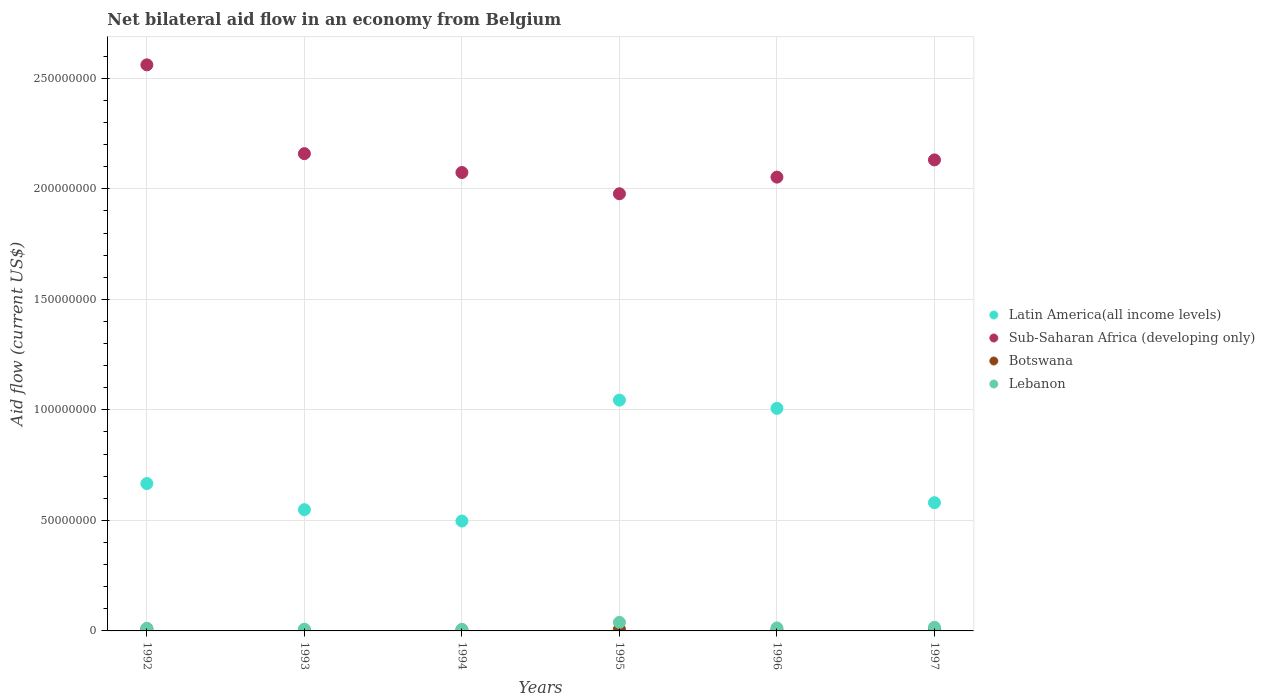What is the net bilateral aid flow in Sub-Saharan Africa (developing only) in 1993?
Provide a succinct answer. 2.16e+08. Across all years, what is the maximum net bilateral aid flow in Botswana?
Keep it short and to the point. 9.20e+05. Across all years, what is the minimum net bilateral aid flow in Sub-Saharan Africa (developing only)?
Your answer should be compact. 1.98e+08. What is the total net bilateral aid flow in Latin America(all income levels) in the graph?
Give a very brief answer. 4.34e+08. What is the difference between the net bilateral aid flow in Latin America(all income levels) in 1994 and that in 1997?
Keep it short and to the point. -8.31e+06. What is the difference between the net bilateral aid flow in Botswana in 1992 and the net bilateral aid flow in Lebanon in 1997?
Give a very brief answer. -7.40e+05. What is the average net bilateral aid flow in Botswana per year?
Give a very brief answer. 5.25e+05. In the year 1997, what is the difference between the net bilateral aid flow in Sub-Saharan Africa (developing only) and net bilateral aid flow in Botswana?
Your response must be concise. 2.13e+08. In how many years, is the net bilateral aid flow in Latin America(all income levels) greater than 30000000 US$?
Your answer should be compact. 6. What is the ratio of the net bilateral aid flow in Botswana in 1992 to that in 1995?
Offer a terse response. 1.23. Is the difference between the net bilateral aid flow in Sub-Saharan Africa (developing only) in 1996 and 1997 greater than the difference between the net bilateral aid flow in Botswana in 1996 and 1997?
Ensure brevity in your answer.  No. What is the difference between the highest and the second highest net bilateral aid flow in Latin America(all income levels)?
Keep it short and to the point. 3.74e+06. What is the difference between the highest and the lowest net bilateral aid flow in Botswana?
Offer a very short reply. 6.50e+05. Is it the case that in every year, the sum of the net bilateral aid flow in Lebanon and net bilateral aid flow in Botswana  is greater than the sum of net bilateral aid flow in Latin America(all income levels) and net bilateral aid flow in Sub-Saharan Africa (developing only)?
Provide a short and direct response. Yes. What is the difference between two consecutive major ticks on the Y-axis?
Ensure brevity in your answer.  5.00e+07. Are the values on the major ticks of Y-axis written in scientific E-notation?
Your answer should be very brief. No. Does the graph contain grids?
Provide a short and direct response. Yes. Where does the legend appear in the graph?
Your answer should be compact. Center right. How are the legend labels stacked?
Make the answer very short. Vertical. What is the title of the graph?
Keep it short and to the point. Net bilateral aid flow in an economy from Belgium. Does "South Asia" appear as one of the legend labels in the graph?
Keep it short and to the point. No. What is the label or title of the X-axis?
Your answer should be very brief. Years. What is the label or title of the Y-axis?
Offer a very short reply. Aid flow (current US$). What is the Aid flow (current US$) in Latin America(all income levels) in 1992?
Give a very brief answer. 6.67e+07. What is the Aid flow (current US$) of Sub-Saharan Africa (developing only) in 1992?
Provide a short and direct response. 2.56e+08. What is the Aid flow (current US$) in Botswana in 1992?
Ensure brevity in your answer.  9.20e+05. What is the Aid flow (current US$) of Lebanon in 1992?
Provide a short and direct response. 1.18e+06. What is the Aid flow (current US$) of Latin America(all income levels) in 1993?
Give a very brief answer. 5.49e+07. What is the Aid flow (current US$) of Sub-Saharan Africa (developing only) in 1993?
Your answer should be very brief. 2.16e+08. What is the Aid flow (current US$) in Lebanon in 1993?
Make the answer very short. 7.80e+05. What is the Aid flow (current US$) in Latin America(all income levels) in 1994?
Your answer should be very brief. 4.97e+07. What is the Aid flow (current US$) of Sub-Saharan Africa (developing only) in 1994?
Ensure brevity in your answer.  2.07e+08. What is the Aid flow (current US$) of Lebanon in 1994?
Offer a terse response. 7.10e+05. What is the Aid flow (current US$) of Latin America(all income levels) in 1995?
Your answer should be compact. 1.04e+08. What is the Aid flow (current US$) of Sub-Saharan Africa (developing only) in 1995?
Your response must be concise. 1.98e+08. What is the Aid flow (current US$) in Botswana in 1995?
Offer a very short reply. 7.50e+05. What is the Aid flow (current US$) in Lebanon in 1995?
Provide a succinct answer. 3.86e+06. What is the Aid flow (current US$) of Latin America(all income levels) in 1996?
Offer a terse response. 1.01e+08. What is the Aid flow (current US$) of Sub-Saharan Africa (developing only) in 1996?
Make the answer very short. 2.05e+08. What is the Aid flow (current US$) of Botswana in 1996?
Your answer should be very brief. 4.20e+05. What is the Aid flow (current US$) in Lebanon in 1996?
Your answer should be compact. 1.35e+06. What is the Aid flow (current US$) of Latin America(all income levels) in 1997?
Your answer should be very brief. 5.80e+07. What is the Aid flow (current US$) of Sub-Saharan Africa (developing only) in 1997?
Make the answer very short. 2.13e+08. What is the Aid flow (current US$) of Botswana in 1997?
Ensure brevity in your answer.  4.00e+05. What is the Aid flow (current US$) in Lebanon in 1997?
Offer a terse response. 1.66e+06. Across all years, what is the maximum Aid flow (current US$) in Latin America(all income levels)?
Offer a terse response. 1.04e+08. Across all years, what is the maximum Aid flow (current US$) of Sub-Saharan Africa (developing only)?
Your response must be concise. 2.56e+08. Across all years, what is the maximum Aid flow (current US$) of Botswana?
Offer a terse response. 9.20e+05. Across all years, what is the maximum Aid flow (current US$) of Lebanon?
Your answer should be compact. 3.86e+06. Across all years, what is the minimum Aid flow (current US$) in Latin America(all income levels)?
Offer a very short reply. 4.97e+07. Across all years, what is the minimum Aid flow (current US$) in Sub-Saharan Africa (developing only)?
Keep it short and to the point. 1.98e+08. Across all years, what is the minimum Aid flow (current US$) of Botswana?
Ensure brevity in your answer.  2.70e+05. Across all years, what is the minimum Aid flow (current US$) of Lebanon?
Offer a very short reply. 7.10e+05. What is the total Aid flow (current US$) of Latin America(all income levels) in the graph?
Your answer should be very brief. 4.34e+08. What is the total Aid flow (current US$) of Sub-Saharan Africa (developing only) in the graph?
Offer a terse response. 1.30e+09. What is the total Aid flow (current US$) in Botswana in the graph?
Give a very brief answer. 3.15e+06. What is the total Aid flow (current US$) of Lebanon in the graph?
Make the answer very short. 9.54e+06. What is the difference between the Aid flow (current US$) of Latin America(all income levels) in 1992 and that in 1993?
Your answer should be very brief. 1.18e+07. What is the difference between the Aid flow (current US$) in Sub-Saharan Africa (developing only) in 1992 and that in 1993?
Provide a succinct answer. 4.02e+07. What is the difference between the Aid flow (current US$) in Botswana in 1992 and that in 1993?
Keep it short and to the point. 6.50e+05. What is the difference between the Aid flow (current US$) in Latin America(all income levels) in 1992 and that in 1994?
Offer a terse response. 1.70e+07. What is the difference between the Aid flow (current US$) in Sub-Saharan Africa (developing only) in 1992 and that in 1994?
Your answer should be very brief. 4.87e+07. What is the difference between the Aid flow (current US$) of Botswana in 1992 and that in 1994?
Give a very brief answer. 5.30e+05. What is the difference between the Aid flow (current US$) in Latin America(all income levels) in 1992 and that in 1995?
Offer a very short reply. -3.78e+07. What is the difference between the Aid flow (current US$) in Sub-Saharan Africa (developing only) in 1992 and that in 1995?
Make the answer very short. 5.83e+07. What is the difference between the Aid flow (current US$) of Botswana in 1992 and that in 1995?
Make the answer very short. 1.70e+05. What is the difference between the Aid flow (current US$) in Lebanon in 1992 and that in 1995?
Your response must be concise. -2.68e+06. What is the difference between the Aid flow (current US$) of Latin America(all income levels) in 1992 and that in 1996?
Keep it short and to the point. -3.40e+07. What is the difference between the Aid flow (current US$) in Sub-Saharan Africa (developing only) in 1992 and that in 1996?
Your answer should be very brief. 5.08e+07. What is the difference between the Aid flow (current US$) in Latin America(all income levels) in 1992 and that in 1997?
Offer a terse response. 8.66e+06. What is the difference between the Aid flow (current US$) of Sub-Saharan Africa (developing only) in 1992 and that in 1997?
Ensure brevity in your answer.  4.30e+07. What is the difference between the Aid flow (current US$) in Botswana in 1992 and that in 1997?
Provide a succinct answer. 5.20e+05. What is the difference between the Aid flow (current US$) in Lebanon in 1992 and that in 1997?
Your response must be concise. -4.80e+05. What is the difference between the Aid flow (current US$) of Latin America(all income levels) in 1993 and that in 1994?
Give a very brief answer. 5.16e+06. What is the difference between the Aid flow (current US$) of Sub-Saharan Africa (developing only) in 1993 and that in 1994?
Offer a very short reply. 8.53e+06. What is the difference between the Aid flow (current US$) of Botswana in 1993 and that in 1994?
Offer a terse response. -1.20e+05. What is the difference between the Aid flow (current US$) of Latin America(all income levels) in 1993 and that in 1995?
Ensure brevity in your answer.  -4.96e+07. What is the difference between the Aid flow (current US$) of Sub-Saharan Africa (developing only) in 1993 and that in 1995?
Give a very brief answer. 1.82e+07. What is the difference between the Aid flow (current US$) in Botswana in 1993 and that in 1995?
Your response must be concise. -4.80e+05. What is the difference between the Aid flow (current US$) of Lebanon in 1993 and that in 1995?
Give a very brief answer. -3.08e+06. What is the difference between the Aid flow (current US$) in Latin America(all income levels) in 1993 and that in 1996?
Keep it short and to the point. -4.58e+07. What is the difference between the Aid flow (current US$) of Sub-Saharan Africa (developing only) in 1993 and that in 1996?
Provide a succinct answer. 1.06e+07. What is the difference between the Aid flow (current US$) in Botswana in 1993 and that in 1996?
Offer a very short reply. -1.50e+05. What is the difference between the Aid flow (current US$) in Lebanon in 1993 and that in 1996?
Give a very brief answer. -5.70e+05. What is the difference between the Aid flow (current US$) in Latin America(all income levels) in 1993 and that in 1997?
Ensure brevity in your answer.  -3.15e+06. What is the difference between the Aid flow (current US$) in Sub-Saharan Africa (developing only) in 1993 and that in 1997?
Keep it short and to the point. 2.83e+06. What is the difference between the Aid flow (current US$) of Lebanon in 1993 and that in 1997?
Give a very brief answer. -8.80e+05. What is the difference between the Aid flow (current US$) in Latin America(all income levels) in 1994 and that in 1995?
Give a very brief answer. -5.47e+07. What is the difference between the Aid flow (current US$) in Sub-Saharan Africa (developing only) in 1994 and that in 1995?
Make the answer very short. 9.62e+06. What is the difference between the Aid flow (current US$) in Botswana in 1994 and that in 1995?
Your answer should be very brief. -3.60e+05. What is the difference between the Aid flow (current US$) in Lebanon in 1994 and that in 1995?
Your answer should be very brief. -3.15e+06. What is the difference between the Aid flow (current US$) of Latin America(all income levels) in 1994 and that in 1996?
Keep it short and to the point. -5.10e+07. What is the difference between the Aid flow (current US$) in Sub-Saharan Africa (developing only) in 1994 and that in 1996?
Provide a short and direct response. 2.09e+06. What is the difference between the Aid flow (current US$) of Lebanon in 1994 and that in 1996?
Your response must be concise. -6.40e+05. What is the difference between the Aid flow (current US$) of Latin America(all income levels) in 1994 and that in 1997?
Your answer should be very brief. -8.31e+06. What is the difference between the Aid flow (current US$) of Sub-Saharan Africa (developing only) in 1994 and that in 1997?
Keep it short and to the point. -5.70e+06. What is the difference between the Aid flow (current US$) of Botswana in 1994 and that in 1997?
Give a very brief answer. -10000. What is the difference between the Aid flow (current US$) of Lebanon in 1994 and that in 1997?
Provide a short and direct response. -9.50e+05. What is the difference between the Aid flow (current US$) in Latin America(all income levels) in 1995 and that in 1996?
Your response must be concise. 3.74e+06. What is the difference between the Aid flow (current US$) in Sub-Saharan Africa (developing only) in 1995 and that in 1996?
Keep it short and to the point. -7.53e+06. What is the difference between the Aid flow (current US$) of Lebanon in 1995 and that in 1996?
Your answer should be very brief. 2.51e+06. What is the difference between the Aid flow (current US$) in Latin America(all income levels) in 1995 and that in 1997?
Make the answer very short. 4.64e+07. What is the difference between the Aid flow (current US$) of Sub-Saharan Africa (developing only) in 1995 and that in 1997?
Make the answer very short. -1.53e+07. What is the difference between the Aid flow (current US$) in Botswana in 1995 and that in 1997?
Make the answer very short. 3.50e+05. What is the difference between the Aid flow (current US$) of Lebanon in 1995 and that in 1997?
Your answer should be compact. 2.20e+06. What is the difference between the Aid flow (current US$) of Latin America(all income levels) in 1996 and that in 1997?
Your response must be concise. 4.27e+07. What is the difference between the Aid flow (current US$) in Sub-Saharan Africa (developing only) in 1996 and that in 1997?
Offer a terse response. -7.79e+06. What is the difference between the Aid flow (current US$) in Botswana in 1996 and that in 1997?
Your answer should be compact. 2.00e+04. What is the difference between the Aid flow (current US$) in Lebanon in 1996 and that in 1997?
Give a very brief answer. -3.10e+05. What is the difference between the Aid flow (current US$) of Latin America(all income levels) in 1992 and the Aid flow (current US$) of Sub-Saharan Africa (developing only) in 1993?
Your answer should be very brief. -1.49e+08. What is the difference between the Aid flow (current US$) of Latin America(all income levels) in 1992 and the Aid flow (current US$) of Botswana in 1993?
Give a very brief answer. 6.64e+07. What is the difference between the Aid flow (current US$) in Latin America(all income levels) in 1992 and the Aid flow (current US$) in Lebanon in 1993?
Your answer should be very brief. 6.59e+07. What is the difference between the Aid flow (current US$) of Sub-Saharan Africa (developing only) in 1992 and the Aid flow (current US$) of Botswana in 1993?
Offer a terse response. 2.56e+08. What is the difference between the Aid flow (current US$) in Sub-Saharan Africa (developing only) in 1992 and the Aid flow (current US$) in Lebanon in 1993?
Your response must be concise. 2.55e+08. What is the difference between the Aid flow (current US$) in Latin America(all income levels) in 1992 and the Aid flow (current US$) in Sub-Saharan Africa (developing only) in 1994?
Your response must be concise. -1.41e+08. What is the difference between the Aid flow (current US$) in Latin America(all income levels) in 1992 and the Aid flow (current US$) in Botswana in 1994?
Provide a succinct answer. 6.63e+07. What is the difference between the Aid flow (current US$) in Latin America(all income levels) in 1992 and the Aid flow (current US$) in Lebanon in 1994?
Ensure brevity in your answer.  6.60e+07. What is the difference between the Aid flow (current US$) in Sub-Saharan Africa (developing only) in 1992 and the Aid flow (current US$) in Botswana in 1994?
Your answer should be very brief. 2.56e+08. What is the difference between the Aid flow (current US$) of Sub-Saharan Africa (developing only) in 1992 and the Aid flow (current US$) of Lebanon in 1994?
Ensure brevity in your answer.  2.55e+08. What is the difference between the Aid flow (current US$) of Latin America(all income levels) in 1992 and the Aid flow (current US$) of Sub-Saharan Africa (developing only) in 1995?
Give a very brief answer. -1.31e+08. What is the difference between the Aid flow (current US$) of Latin America(all income levels) in 1992 and the Aid flow (current US$) of Botswana in 1995?
Your answer should be very brief. 6.59e+07. What is the difference between the Aid flow (current US$) of Latin America(all income levels) in 1992 and the Aid flow (current US$) of Lebanon in 1995?
Provide a short and direct response. 6.28e+07. What is the difference between the Aid flow (current US$) in Sub-Saharan Africa (developing only) in 1992 and the Aid flow (current US$) in Botswana in 1995?
Your answer should be compact. 2.55e+08. What is the difference between the Aid flow (current US$) in Sub-Saharan Africa (developing only) in 1992 and the Aid flow (current US$) in Lebanon in 1995?
Ensure brevity in your answer.  2.52e+08. What is the difference between the Aid flow (current US$) of Botswana in 1992 and the Aid flow (current US$) of Lebanon in 1995?
Your response must be concise. -2.94e+06. What is the difference between the Aid flow (current US$) of Latin America(all income levels) in 1992 and the Aid flow (current US$) of Sub-Saharan Africa (developing only) in 1996?
Offer a terse response. -1.39e+08. What is the difference between the Aid flow (current US$) in Latin America(all income levels) in 1992 and the Aid flow (current US$) in Botswana in 1996?
Your response must be concise. 6.62e+07. What is the difference between the Aid flow (current US$) of Latin America(all income levels) in 1992 and the Aid flow (current US$) of Lebanon in 1996?
Your response must be concise. 6.53e+07. What is the difference between the Aid flow (current US$) of Sub-Saharan Africa (developing only) in 1992 and the Aid flow (current US$) of Botswana in 1996?
Offer a very short reply. 2.56e+08. What is the difference between the Aid flow (current US$) of Sub-Saharan Africa (developing only) in 1992 and the Aid flow (current US$) of Lebanon in 1996?
Offer a very short reply. 2.55e+08. What is the difference between the Aid flow (current US$) of Botswana in 1992 and the Aid flow (current US$) of Lebanon in 1996?
Offer a terse response. -4.30e+05. What is the difference between the Aid flow (current US$) of Latin America(all income levels) in 1992 and the Aid flow (current US$) of Sub-Saharan Africa (developing only) in 1997?
Your answer should be compact. -1.46e+08. What is the difference between the Aid flow (current US$) in Latin America(all income levels) in 1992 and the Aid flow (current US$) in Botswana in 1997?
Your answer should be compact. 6.63e+07. What is the difference between the Aid flow (current US$) of Latin America(all income levels) in 1992 and the Aid flow (current US$) of Lebanon in 1997?
Offer a terse response. 6.50e+07. What is the difference between the Aid flow (current US$) in Sub-Saharan Africa (developing only) in 1992 and the Aid flow (current US$) in Botswana in 1997?
Offer a very short reply. 2.56e+08. What is the difference between the Aid flow (current US$) in Sub-Saharan Africa (developing only) in 1992 and the Aid flow (current US$) in Lebanon in 1997?
Give a very brief answer. 2.54e+08. What is the difference between the Aid flow (current US$) in Botswana in 1992 and the Aid flow (current US$) in Lebanon in 1997?
Provide a succinct answer. -7.40e+05. What is the difference between the Aid flow (current US$) in Latin America(all income levels) in 1993 and the Aid flow (current US$) in Sub-Saharan Africa (developing only) in 1994?
Offer a terse response. -1.53e+08. What is the difference between the Aid flow (current US$) in Latin America(all income levels) in 1993 and the Aid flow (current US$) in Botswana in 1994?
Give a very brief answer. 5.45e+07. What is the difference between the Aid flow (current US$) in Latin America(all income levels) in 1993 and the Aid flow (current US$) in Lebanon in 1994?
Your answer should be very brief. 5.42e+07. What is the difference between the Aid flow (current US$) of Sub-Saharan Africa (developing only) in 1993 and the Aid flow (current US$) of Botswana in 1994?
Your answer should be very brief. 2.16e+08. What is the difference between the Aid flow (current US$) of Sub-Saharan Africa (developing only) in 1993 and the Aid flow (current US$) of Lebanon in 1994?
Ensure brevity in your answer.  2.15e+08. What is the difference between the Aid flow (current US$) of Botswana in 1993 and the Aid flow (current US$) of Lebanon in 1994?
Offer a very short reply. -4.40e+05. What is the difference between the Aid flow (current US$) in Latin America(all income levels) in 1993 and the Aid flow (current US$) in Sub-Saharan Africa (developing only) in 1995?
Your answer should be compact. -1.43e+08. What is the difference between the Aid flow (current US$) of Latin America(all income levels) in 1993 and the Aid flow (current US$) of Botswana in 1995?
Provide a succinct answer. 5.41e+07. What is the difference between the Aid flow (current US$) of Latin America(all income levels) in 1993 and the Aid flow (current US$) of Lebanon in 1995?
Your answer should be compact. 5.10e+07. What is the difference between the Aid flow (current US$) of Sub-Saharan Africa (developing only) in 1993 and the Aid flow (current US$) of Botswana in 1995?
Keep it short and to the point. 2.15e+08. What is the difference between the Aid flow (current US$) in Sub-Saharan Africa (developing only) in 1993 and the Aid flow (current US$) in Lebanon in 1995?
Your answer should be very brief. 2.12e+08. What is the difference between the Aid flow (current US$) of Botswana in 1993 and the Aid flow (current US$) of Lebanon in 1995?
Ensure brevity in your answer.  -3.59e+06. What is the difference between the Aid flow (current US$) in Latin America(all income levels) in 1993 and the Aid flow (current US$) in Sub-Saharan Africa (developing only) in 1996?
Keep it short and to the point. -1.50e+08. What is the difference between the Aid flow (current US$) of Latin America(all income levels) in 1993 and the Aid flow (current US$) of Botswana in 1996?
Offer a very short reply. 5.44e+07. What is the difference between the Aid flow (current US$) in Latin America(all income levels) in 1993 and the Aid flow (current US$) in Lebanon in 1996?
Make the answer very short. 5.35e+07. What is the difference between the Aid flow (current US$) of Sub-Saharan Africa (developing only) in 1993 and the Aid flow (current US$) of Botswana in 1996?
Ensure brevity in your answer.  2.15e+08. What is the difference between the Aid flow (current US$) of Sub-Saharan Africa (developing only) in 1993 and the Aid flow (current US$) of Lebanon in 1996?
Ensure brevity in your answer.  2.15e+08. What is the difference between the Aid flow (current US$) in Botswana in 1993 and the Aid flow (current US$) in Lebanon in 1996?
Your response must be concise. -1.08e+06. What is the difference between the Aid flow (current US$) of Latin America(all income levels) in 1993 and the Aid flow (current US$) of Sub-Saharan Africa (developing only) in 1997?
Your answer should be compact. -1.58e+08. What is the difference between the Aid flow (current US$) of Latin America(all income levels) in 1993 and the Aid flow (current US$) of Botswana in 1997?
Your answer should be compact. 5.45e+07. What is the difference between the Aid flow (current US$) in Latin America(all income levels) in 1993 and the Aid flow (current US$) in Lebanon in 1997?
Ensure brevity in your answer.  5.32e+07. What is the difference between the Aid flow (current US$) of Sub-Saharan Africa (developing only) in 1993 and the Aid flow (current US$) of Botswana in 1997?
Provide a succinct answer. 2.16e+08. What is the difference between the Aid flow (current US$) of Sub-Saharan Africa (developing only) in 1993 and the Aid flow (current US$) of Lebanon in 1997?
Ensure brevity in your answer.  2.14e+08. What is the difference between the Aid flow (current US$) in Botswana in 1993 and the Aid flow (current US$) in Lebanon in 1997?
Ensure brevity in your answer.  -1.39e+06. What is the difference between the Aid flow (current US$) in Latin America(all income levels) in 1994 and the Aid flow (current US$) in Sub-Saharan Africa (developing only) in 1995?
Provide a succinct answer. -1.48e+08. What is the difference between the Aid flow (current US$) of Latin America(all income levels) in 1994 and the Aid flow (current US$) of Botswana in 1995?
Ensure brevity in your answer.  4.90e+07. What is the difference between the Aid flow (current US$) of Latin America(all income levels) in 1994 and the Aid flow (current US$) of Lebanon in 1995?
Your answer should be very brief. 4.58e+07. What is the difference between the Aid flow (current US$) of Sub-Saharan Africa (developing only) in 1994 and the Aid flow (current US$) of Botswana in 1995?
Ensure brevity in your answer.  2.07e+08. What is the difference between the Aid flow (current US$) in Sub-Saharan Africa (developing only) in 1994 and the Aid flow (current US$) in Lebanon in 1995?
Offer a very short reply. 2.04e+08. What is the difference between the Aid flow (current US$) of Botswana in 1994 and the Aid flow (current US$) of Lebanon in 1995?
Offer a terse response. -3.47e+06. What is the difference between the Aid flow (current US$) of Latin America(all income levels) in 1994 and the Aid flow (current US$) of Sub-Saharan Africa (developing only) in 1996?
Offer a terse response. -1.56e+08. What is the difference between the Aid flow (current US$) in Latin America(all income levels) in 1994 and the Aid flow (current US$) in Botswana in 1996?
Your response must be concise. 4.93e+07. What is the difference between the Aid flow (current US$) in Latin America(all income levels) in 1994 and the Aid flow (current US$) in Lebanon in 1996?
Offer a terse response. 4.84e+07. What is the difference between the Aid flow (current US$) of Sub-Saharan Africa (developing only) in 1994 and the Aid flow (current US$) of Botswana in 1996?
Offer a very short reply. 2.07e+08. What is the difference between the Aid flow (current US$) in Sub-Saharan Africa (developing only) in 1994 and the Aid flow (current US$) in Lebanon in 1996?
Provide a short and direct response. 2.06e+08. What is the difference between the Aid flow (current US$) in Botswana in 1994 and the Aid flow (current US$) in Lebanon in 1996?
Provide a short and direct response. -9.60e+05. What is the difference between the Aid flow (current US$) of Latin America(all income levels) in 1994 and the Aid flow (current US$) of Sub-Saharan Africa (developing only) in 1997?
Offer a terse response. -1.63e+08. What is the difference between the Aid flow (current US$) in Latin America(all income levels) in 1994 and the Aid flow (current US$) in Botswana in 1997?
Offer a very short reply. 4.93e+07. What is the difference between the Aid flow (current US$) of Latin America(all income levels) in 1994 and the Aid flow (current US$) of Lebanon in 1997?
Keep it short and to the point. 4.80e+07. What is the difference between the Aid flow (current US$) in Sub-Saharan Africa (developing only) in 1994 and the Aid flow (current US$) in Botswana in 1997?
Provide a short and direct response. 2.07e+08. What is the difference between the Aid flow (current US$) of Sub-Saharan Africa (developing only) in 1994 and the Aid flow (current US$) of Lebanon in 1997?
Give a very brief answer. 2.06e+08. What is the difference between the Aid flow (current US$) in Botswana in 1994 and the Aid flow (current US$) in Lebanon in 1997?
Offer a terse response. -1.27e+06. What is the difference between the Aid flow (current US$) of Latin America(all income levels) in 1995 and the Aid flow (current US$) of Sub-Saharan Africa (developing only) in 1996?
Give a very brief answer. -1.01e+08. What is the difference between the Aid flow (current US$) in Latin America(all income levels) in 1995 and the Aid flow (current US$) in Botswana in 1996?
Make the answer very short. 1.04e+08. What is the difference between the Aid flow (current US$) of Latin America(all income levels) in 1995 and the Aid flow (current US$) of Lebanon in 1996?
Your response must be concise. 1.03e+08. What is the difference between the Aid flow (current US$) in Sub-Saharan Africa (developing only) in 1995 and the Aid flow (current US$) in Botswana in 1996?
Offer a terse response. 1.97e+08. What is the difference between the Aid flow (current US$) in Sub-Saharan Africa (developing only) in 1995 and the Aid flow (current US$) in Lebanon in 1996?
Offer a terse response. 1.96e+08. What is the difference between the Aid flow (current US$) of Botswana in 1995 and the Aid flow (current US$) of Lebanon in 1996?
Provide a short and direct response. -6.00e+05. What is the difference between the Aid flow (current US$) in Latin America(all income levels) in 1995 and the Aid flow (current US$) in Sub-Saharan Africa (developing only) in 1997?
Offer a terse response. -1.09e+08. What is the difference between the Aid flow (current US$) in Latin America(all income levels) in 1995 and the Aid flow (current US$) in Botswana in 1997?
Give a very brief answer. 1.04e+08. What is the difference between the Aid flow (current US$) of Latin America(all income levels) in 1995 and the Aid flow (current US$) of Lebanon in 1997?
Your response must be concise. 1.03e+08. What is the difference between the Aid flow (current US$) of Sub-Saharan Africa (developing only) in 1995 and the Aid flow (current US$) of Botswana in 1997?
Provide a short and direct response. 1.97e+08. What is the difference between the Aid flow (current US$) in Sub-Saharan Africa (developing only) in 1995 and the Aid flow (current US$) in Lebanon in 1997?
Offer a terse response. 1.96e+08. What is the difference between the Aid flow (current US$) in Botswana in 1995 and the Aid flow (current US$) in Lebanon in 1997?
Keep it short and to the point. -9.10e+05. What is the difference between the Aid flow (current US$) in Latin America(all income levels) in 1996 and the Aid flow (current US$) in Sub-Saharan Africa (developing only) in 1997?
Offer a terse response. -1.12e+08. What is the difference between the Aid flow (current US$) of Latin America(all income levels) in 1996 and the Aid flow (current US$) of Botswana in 1997?
Make the answer very short. 1.00e+08. What is the difference between the Aid flow (current US$) of Latin America(all income levels) in 1996 and the Aid flow (current US$) of Lebanon in 1997?
Offer a very short reply. 9.90e+07. What is the difference between the Aid flow (current US$) of Sub-Saharan Africa (developing only) in 1996 and the Aid flow (current US$) of Botswana in 1997?
Your answer should be very brief. 2.05e+08. What is the difference between the Aid flow (current US$) of Sub-Saharan Africa (developing only) in 1996 and the Aid flow (current US$) of Lebanon in 1997?
Your response must be concise. 2.04e+08. What is the difference between the Aid flow (current US$) in Botswana in 1996 and the Aid flow (current US$) in Lebanon in 1997?
Your answer should be compact. -1.24e+06. What is the average Aid flow (current US$) of Latin America(all income levels) per year?
Provide a succinct answer. 7.24e+07. What is the average Aid flow (current US$) in Sub-Saharan Africa (developing only) per year?
Provide a short and direct response. 2.16e+08. What is the average Aid flow (current US$) in Botswana per year?
Your answer should be compact. 5.25e+05. What is the average Aid flow (current US$) in Lebanon per year?
Your answer should be compact. 1.59e+06. In the year 1992, what is the difference between the Aid flow (current US$) of Latin America(all income levels) and Aid flow (current US$) of Sub-Saharan Africa (developing only)?
Provide a short and direct response. -1.89e+08. In the year 1992, what is the difference between the Aid flow (current US$) in Latin America(all income levels) and Aid flow (current US$) in Botswana?
Give a very brief answer. 6.58e+07. In the year 1992, what is the difference between the Aid flow (current US$) in Latin America(all income levels) and Aid flow (current US$) in Lebanon?
Provide a short and direct response. 6.55e+07. In the year 1992, what is the difference between the Aid flow (current US$) of Sub-Saharan Africa (developing only) and Aid flow (current US$) of Botswana?
Offer a very short reply. 2.55e+08. In the year 1992, what is the difference between the Aid flow (current US$) in Sub-Saharan Africa (developing only) and Aid flow (current US$) in Lebanon?
Your answer should be compact. 2.55e+08. In the year 1993, what is the difference between the Aid flow (current US$) of Latin America(all income levels) and Aid flow (current US$) of Sub-Saharan Africa (developing only)?
Offer a terse response. -1.61e+08. In the year 1993, what is the difference between the Aid flow (current US$) in Latin America(all income levels) and Aid flow (current US$) in Botswana?
Ensure brevity in your answer.  5.46e+07. In the year 1993, what is the difference between the Aid flow (current US$) in Latin America(all income levels) and Aid flow (current US$) in Lebanon?
Make the answer very short. 5.41e+07. In the year 1993, what is the difference between the Aid flow (current US$) of Sub-Saharan Africa (developing only) and Aid flow (current US$) of Botswana?
Offer a very short reply. 2.16e+08. In the year 1993, what is the difference between the Aid flow (current US$) in Sub-Saharan Africa (developing only) and Aid flow (current US$) in Lebanon?
Make the answer very short. 2.15e+08. In the year 1993, what is the difference between the Aid flow (current US$) in Botswana and Aid flow (current US$) in Lebanon?
Make the answer very short. -5.10e+05. In the year 1994, what is the difference between the Aid flow (current US$) in Latin America(all income levels) and Aid flow (current US$) in Sub-Saharan Africa (developing only)?
Make the answer very short. -1.58e+08. In the year 1994, what is the difference between the Aid flow (current US$) in Latin America(all income levels) and Aid flow (current US$) in Botswana?
Give a very brief answer. 4.93e+07. In the year 1994, what is the difference between the Aid flow (current US$) in Latin America(all income levels) and Aid flow (current US$) in Lebanon?
Keep it short and to the point. 4.90e+07. In the year 1994, what is the difference between the Aid flow (current US$) in Sub-Saharan Africa (developing only) and Aid flow (current US$) in Botswana?
Give a very brief answer. 2.07e+08. In the year 1994, what is the difference between the Aid flow (current US$) of Sub-Saharan Africa (developing only) and Aid flow (current US$) of Lebanon?
Ensure brevity in your answer.  2.07e+08. In the year 1994, what is the difference between the Aid flow (current US$) in Botswana and Aid flow (current US$) in Lebanon?
Ensure brevity in your answer.  -3.20e+05. In the year 1995, what is the difference between the Aid flow (current US$) in Latin America(all income levels) and Aid flow (current US$) in Sub-Saharan Africa (developing only)?
Your answer should be very brief. -9.33e+07. In the year 1995, what is the difference between the Aid flow (current US$) of Latin America(all income levels) and Aid flow (current US$) of Botswana?
Offer a terse response. 1.04e+08. In the year 1995, what is the difference between the Aid flow (current US$) of Latin America(all income levels) and Aid flow (current US$) of Lebanon?
Provide a succinct answer. 1.01e+08. In the year 1995, what is the difference between the Aid flow (current US$) in Sub-Saharan Africa (developing only) and Aid flow (current US$) in Botswana?
Ensure brevity in your answer.  1.97e+08. In the year 1995, what is the difference between the Aid flow (current US$) in Sub-Saharan Africa (developing only) and Aid flow (current US$) in Lebanon?
Your answer should be very brief. 1.94e+08. In the year 1995, what is the difference between the Aid flow (current US$) of Botswana and Aid flow (current US$) of Lebanon?
Give a very brief answer. -3.11e+06. In the year 1996, what is the difference between the Aid flow (current US$) of Latin America(all income levels) and Aid flow (current US$) of Sub-Saharan Africa (developing only)?
Your response must be concise. -1.05e+08. In the year 1996, what is the difference between the Aid flow (current US$) in Latin America(all income levels) and Aid flow (current US$) in Botswana?
Provide a succinct answer. 1.00e+08. In the year 1996, what is the difference between the Aid flow (current US$) in Latin America(all income levels) and Aid flow (current US$) in Lebanon?
Your answer should be compact. 9.93e+07. In the year 1996, what is the difference between the Aid flow (current US$) in Sub-Saharan Africa (developing only) and Aid flow (current US$) in Botswana?
Make the answer very short. 2.05e+08. In the year 1996, what is the difference between the Aid flow (current US$) of Sub-Saharan Africa (developing only) and Aid flow (current US$) of Lebanon?
Make the answer very short. 2.04e+08. In the year 1996, what is the difference between the Aid flow (current US$) of Botswana and Aid flow (current US$) of Lebanon?
Ensure brevity in your answer.  -9.30e+05. In the year 1997, what is the difference between the Aid flow (current US$) in Latin America(all income levels) and Aid flow (current US$) in Sub-Saharan Africa (developing only)?
Offer a very short reply. -1.55e+08. In the year 1997, what is the difference between the Aid flow (current US$) in Latin America(all income levels) and Aid flow (current US$) in Botswana?
Make the answer very short. 5.76e+07. In the year 1997, what is the difference between the Aid flow (current US$) of Latin America(all income levels) and Aid flow (current US$) of Lebanon?
Offer a terse response. 5.64e+07. In the year 1997, what is the difference between the Aid flow (current US$) in Sub-Saharan Africa (developing only) and Aid flow (current US$) in Botswana?
Keep it short and to the point. 2.13e+08. In the year 1997, what is the difference between the Aid flow (current US$) of Sub-Saharan Africa (developing only) and Aid flow (current US$) of Lebanon?
Your answer should be very brief. 2.11e+08. In the year 1997, what is the difference between the Aid flow (current US$) of Botswana and Aid flow (current US$) of Lebanon?
Provide a succinct answer. -1.26e+06. What is the ratio of the Aid flow (current US$) in Latin America(all income levels) in 1992 to that in 1993?
Provide a short and direct response. 1.22. What is the ratio of the Aid flow (current US$) of Sub-Saharan Africa (developing only) in 1992 to that in 1993?
Offer a very short reply. 1.19. What is the ratio of the Aid flow (current US$) in Botswana in 1992 to that in 1993?
Your answer should be very brief. 3.41. What is the ratio of the Aid flow (current US$) in Lebanon in 1992 to that in 1993?
Provide a short and direct response. 1.51. What is the ratio of the Aid flow (current US$) of Latin America(all income levels) in 1992 to that in 1994?
Your answer should be very brief. 1.34. What is the ratio of the Aid flow (current US$) in Sub-Saharan Africa (developing only) in 1992 to that in 1994?
Keep it short and to the point. 1.23. What is the ratio of the Aid flow (current US$) of Botswana in 1992 to that in 1994?
Your response must be concise. 2.36. What is the ratio of the Aid flow (current US$) of Lebanon in 1992 to that in 1994?
Give a very brief answer. 1.66. What is the ratio of the Aid flow (current US$) in Latin America(all income levels) in 1992 to that in 1995?
Keep it short and to the point. 0.64. What is the ratio of the Aid flow (current US$) of Sub-Saharan Africa (developing only) in 1992 to that in 1995?
Your answer should be very brief. 1.29. What is the ratio of the Aid flow (current US$) in Botswana in 1992 to that in 1995?
Your answer should be compact. 1.23. What is the ratio of the Aid flow (current US$) in Lebanon in 1992 to that in 1995?
Make the answer very short. 0.31. What is the ratio of the Aid flow (current US$) in Latin America(all income levels) in 1992 to that in 1996?
Ensure brevity in your answer.  0.66. What is the ratio of the Aid flow (current US$) of Sub-Saharan Africa (developing only) in 1992 to that in 1996?
Provide a succinct answer. 1.25. What is the ratio of the Aid flow (current US$) of Botswana in 1992 to that in 1996?
Your answer should be very brief. 2.19. What is the ratio of the Aid flow (current US$) in Lebanon in 1992 to that in 1996?
Give a very brief answer. 0.87. What is the ratio of the Aid flow (current US$) in Latin America(all income levels) in 1992 to that in 1997?
Ensure brevity in your answer.  1.15. What is the ratio of the Aid flow (current US$) in Sub-Saharan Africa (developing only) in 1992 to that in 1997?
Make the answer very short. 1.2. What is the ratio of the Aid flow (current US$) in Botswana in 1992 to that in 1997?
Provide a short and direct response. 2.3. What is the ratio of the Aid flow (current US$) of Lebanon in 1992 to that in 1997?
Offer a very short reply. 0.71. What is the ratio of the Aid flow (current US$) of Latin America(all income levels) in 1993 to that in 1994?
Provide a short and direct response. 1.1. What is the ratio of the Aid flow (current US$) in Sub-Saharan Africa (developing only) in 1993 to that in 1994?
Provide a succinct answer. 1.04. What is the ratio of the Aid flow (current US$) of Botswana in 1993 to that in 1994?
Your answer should be very brief. 0.69. What is the ratio of the Aid flow (current US$) in Lebanon in 1993 to that in 1994?
Your response must be concise. 1.1. What is the ratio of the Aid flow (current US$) of Latin America(all income levels) in 1993 to that in 1995?
Provide a succinct answer. 0.53. What is the ratio of the Aid flow (current US$) of Sub-Saharan Africa (developing only) in 1993 to that in 1995?
Offer a terse response. 1.09. What is the ratio of the Aid flow (current US$) in Botswana in 1993 to that in 1995?
Your answer should be very brief. 0.36. What is the ratio of the Aid flow (current US$) in Lebanon in 1993 to that in 1995?
Provide a short and direct response. 0.2. What is the ratio of the Aid flow (current US$) in Latin America(all income levels) in 1993 to that in 1996?
Ensure brevity in your answer.  0.54. What is the ratio of the Aid flow (current US$) of Sub-Saharan Africa (developing only) in 1993 to that in 1996?
Your answer should be compact. 1.05. What is the ratio of the Aid flow (current US$) in Botswana in 1993 to that in 1996?
Provide a short and direct response. 0.64. What is the ratio of the Aid flow (current US$) in Lebanon in 1993 to that in 1996?
Provide a succinct answer. 0.58. What is the ratio of the Aid flow (current US$) in Latin America(all income levels) in 1993 to that in 1997?
Your answer should be very brief. 0.95. What is the ratio of the Aid flow (current US$) of Sub-Saharan Africa (developing only) in 1993 to that in 1997?
Offer a very short reply. 1.01. What is the ratio of the Aid flow (current US$) of Botswana in 1993 to that in 1997?
Your response must be concise. 0.68. What is the ratio of the Aid flow (current US$) of Lebanon in 1993 to that in 1997?
Offer a terse response. 0.47. What is the ratio of the Aid flow (current US$) of Latin America(all income levels) in 1994 to that in 1995?
Your answer should be very brief. 0.48. What is the ratio of the Aid flow (current US$) of Sub-Saharan Africa (developing only) in 1994 to that in 1995?
Your answer should be very brief. 1.05. What is the ratio of the Aid flow (current US$) of Botswana in 1994 to that in 1995?
Keep it short and to the point. 0.52. What is the ratio of the Aid flow (current US$) of Lebanon in 1994 to that in 1995?
Your answer should be very brief. 0.18. What is the ratio of the Aid flow (current US$) of Latin America(all income levels) in 1994 to that in 1996?
Offer a terse response. 0.49. What is the ratio of the Aid flow (current US$) in Sub-Saharan Africa (developing only) in 1994 to that in 1996?
Ensure brevity in your answer.  1.01. What is the ratio of the Aid flow (current US$) of Lebanon in 1994 to that in 1996?
Your answer should be very brief. 0.53. What is the ratio of the Aid flow (current US$) in Latin America(all income levels) in 1994 to that in 1997?
Keep it short and to the point. 0.86. What is the ratio of the Aid flow (current US$) in Sub-Saharan Africa (developing only) in 1994 to that in 1997?
Provide a succinct answer. 0.97. What is the ratio of the Aid flow (current US$) of Botswana in 1994 to that in 1997?
Keep it short and to the point. 0.97. What is the ratio of the Aid flow (current US$) in Lebanon in 1994 to that in 1997?
Your response must be concise. 0.43. What is the ratio of the Aid flow (current US$) in Latin America(all income levels) in 1995 to that in 1996?
Ensure brevity in your answer.  1.04. What is the ratio of the Aid flow (current US$) of Sub-Saharan Africa (developing only) in 1995 to that in 1996?
Your answer should be compact. 0.96. What is the ratio of the Aid flow (current US$) of Botswana in 1995 to that in 1996?
Your response must be concise. 1.79. What is the ratio of the Aid flow (current US$) of Lebanon in 1995 to that in 1996?
Your answer should be very brief. 2.86. What is the ratio of the Aid flow (current US$) of Latin America(all income levels) in 1995 to that in 1997?
Keep it short and to the point. 1.8. What is the ratio of the Aid flow (current US$) of Sub-Saharan Africa (developing only) in 1995 to that in 1997?
Give a very brief answer. 0.93. What is the ratio of the Aid flow (current US$) of Botswana in 1995 to that in 1997?
Your answer should be very brief. 1.88. What is the ratio of the Aid flow (current US$) in Lebanon in 1995 to that in 1997?
Offer a terse response. 2.33. What is the ratio of the Aid flow (current US$) in Latin America(all income levels) in 1996 to that in 1997?
Keep it short and to the point. 1.74. What is the ratio of the Aid flow (current US$) of Sub-Saharan Africa (developing only) in 1996 to that in 1997?
Ensure brevity in your answer.  0.96. What is the ratio of the Aid flow (current US$) of Botswana in 1996 to that in 1997?
Your answer should be very brief. 1.05. What is the ratio of the Aid flow (current US$) in Lebanon in 1996 to that in 1997?
Keep it short and to the point. 0.81. What is the difference between the highest and the second highest Aid flow (current US$) of Latin America(all income levels)?
Your answer should be compact. 3.74e+06. What is the difference between the highest and the second highest Aid flow (current US$) of Sub-Saharan Africa (developing only)?
Provide a short and direct response. 4.02e+07. What is the difference between the highest and the second highest Aid flow (current US$) in Botswana?
Your answer should be very brief. 1.70e+05. What is the difference between the highest and the second highest Aid flow (current US$) in Lebanon?
Keep it short and to the point. 2.20e+06. What is the difference between the highest and the lowest Aid flow (current US$) in Latin America(all income levels)?
Ensure brevity in your answer.  5.47e+07. What is the difference between the highest and the lowest Aid flow (current US$) in Sub-Saharan Africa (developing only)?
Your answer should be compact. 5.83e+07. What is the difference between the highest and the lowest Aid flow (current US$) in Botswana?
Give a very brief answer. 6.50e+05. What is the difference between the highest and the lowest Aid flow (current US$) in Lebanon?
Provide a short and direct response. 3.15e+06. 